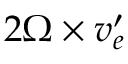<formula> <loc_0><loc_0><loc_500><loc_500>{ 2 \boldsymbol \Omega \times \boldsymbol v _ { e } ^ { \prime } }</formula> 